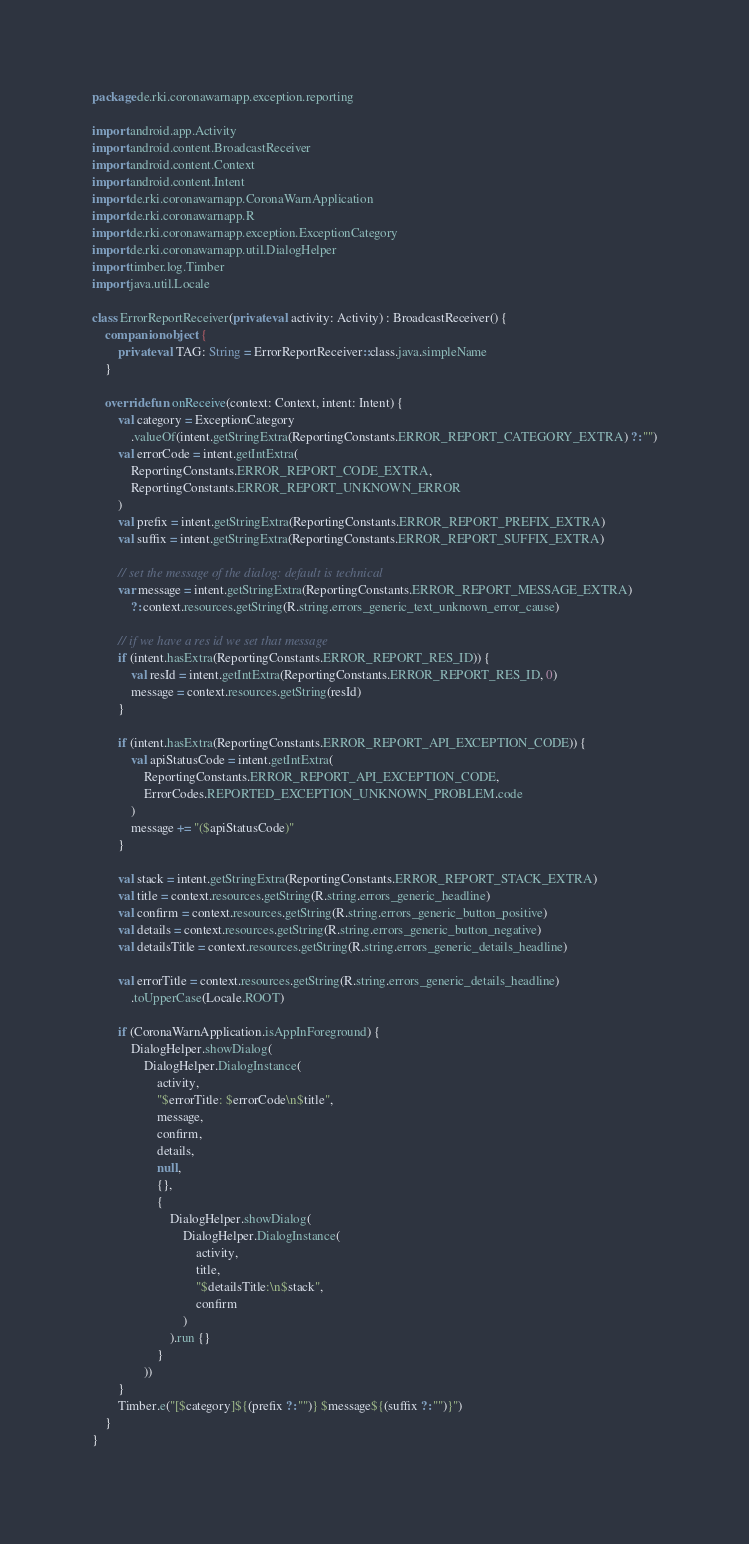Convert code to text. <code><loc_0><loc_0><loc_500><loc_500><_Kotlin_>package de.rki.coronawarnapp.exception.reporting

import android.app.Activity
import android.content.BroadcastReceiver
import android.content.Context
import android.content.Intent
import de.rki.coronawarnapp.CoronaWarnApplication
import de.rki.coronawarnapp.R
import de.rki.coronawarnapp.exception.ExceptionCategory
import de.rki.coronawarnapp.util.DialogHelper
import timber.log.Timber
import java.util.Locale

class ErrorReportReceiver(private val activity: Activity) : BroadcastReceiver() {
    companion object {
        private val TAG: String = ErrorReportReceiver::class.java.simpleName
    }

    override fun onReceive(context: Context, intent: Intent) {
        val category = ExceptionCategory
            .valueOf(intent.getStringExtra(ReportingConstants.ERROR_REPORT_CATEGORY_EXTRA) ?: "")
        val errorCode = intent.getIntExtra(
            ReportingConstants.ERROR_REPORT_CODE_EXTRA,
            ReportingConstants.ERROR_REPORT_UNKNOWN_ERROR
        )
        val prefix = intent.getStringExtra(ReportingConstants.ERROR_REPORT_PREFIX_EXTRA)
        val suffix = intent.getStringExtra(ReportingConstants.ERROR_REPORT_SUFFIX_EXTRA)

        // set the message of the dialog: default is technical
        var message = intent.getStringExtra(ReportingConstants.ERROR_REPORT_MESSAGE_EXTRA)
            ?: context.resources.getString(R.string.errors_generic_text_unknown_error_cause)

        // if we have a res id we set that message
        if (intent.hasExtra(ReportingConstants.ERROR_REPORT_RES_ID)) {
            val resId = intent.getIntExtra(ReportingConstants.ERROR_REPORT_RES_ID, 0)
            message = context.resources.getString(resId)
        }

        if (intent.hasExtra(ReportingConstants.ERROR_REPORT_API_EXCEPTION_CODE)) {
            val apiStatusCode = intent.getIntExtra(
                ReportingConstants.ERROR_REPORT_API_EXCEPTION_CODE,
                ErrorCodes.REPORTED_EXCEPTION_UNKNOWN_PROBLEM.code
            )
            message += "($apiStatusCode)"
        }

        val stack = intent.getStringExtra(ReportingConstants.ERROR_REPORT_STACK_EXTRA)
        val title = context.resources.getString(R.string.errors_generic_headline)
        val confirm = context.resources.getString(R.string.errors_generic_button_positive)
        val details = context.resources.getString(R.string.errors_generic_button_negative)
        val detailsTitle = context.resources.getString(R.string.errors_generic_details_headline)

        val errorTitle = context.resources.getString(R.string.errors_generic_details_headline)
            .toUpperCase(Locale.ROOT)

        if (CoronaWarnApplication.isAppInForeground) {
            DialogHelper.showDialog(
                DialogHelper.DialogInstance(
                    activity,
                    "$errorTitle: $errorCode\n$title",
                    message,
                    confirm,
                    details,
                    null,
                    {},
                    {
                        DialogHelper.showDialog(
                            DialogHelper.DialogInstance(
                                activity,
                                title,
                                "$detailsTitle:\n$stack",
                                confirm
                            )
                        ).run {}
                    }
                ))
        }
        Timber.e("[$category]${(prefix ?: "")} $message${(suffix ?: "")}")
    }
}
</code> 